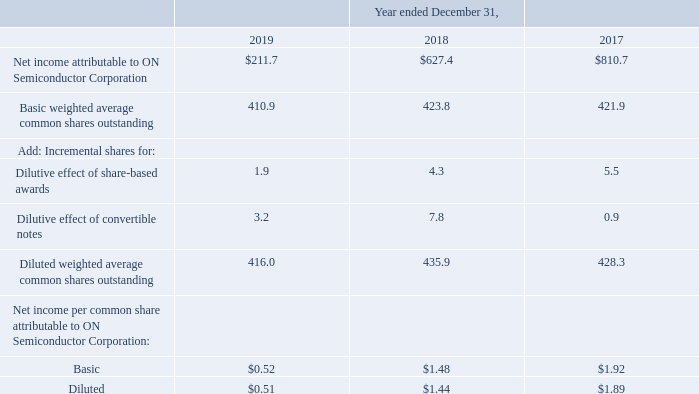Earnings Per Share
Calculations of net income per common share attributable to ON Semiconductor Corporation are as follows (in millions, except per share data):
Basic income per common share is computed by dividing net income attributable to ON Semiconductor Corporation by the weighted average number of common shares outstanding during the period.
To calculate the diluted weighted-average common shares outstanding, the number of incremental shares from the assumed exercise of stock options and assumed issuance of shares relating to RSUs is calculated by applying the treasury stock method. Share-based awards whose impact is considered to be anti-dilutive under the treasury stock method were excluded from the diluted net income per share calculation.
The excluded number of anti-dilutive share-based awards was approximately 0.8 million, 0.6 million and 0.2 million for the years ended December 31, 2019, 2018 and 2017, respectively.
The dilutive impact related to the Company’s 1.00% Notes and 1.625% Notes is determined in accordance with the net share settlement requirements, under which the Company’s convertible notes are assumed to be convertible into cash up to the par value, with the excess of par value being convertible into common stock.
Additionally, if the average price of the Company’s common stock exceeds $ 25.96 per share, with respect to the 1.00% Notes, or $30.70 per share, with respect to the 1.625% Notes, during the relevant reporting period, the effect of the additional potential shares that may be issued related to the warrants that were issued concurrently with the issuance of the convertible notes will also be included in the calculation of diluted weighted-average common shares outstanding.
Prior to conversion, the convertible note hedges are not considered for purposes of the earnings per share calculations, as their effect would be anti-dilutive. Upon conversion, the convertible note hedges are expected to offset the dilutive effect of the 1.00% Notes and 1.625% Notes, respectively, when the stock price is above $18.50 per share, with respect to the 1.00% Notes, and $20.72 per share, with respect to the 1.625% Notes.
How is Basic income per common share computed? Dividing net income attributable to on semiconductor corporation by the weighted average number of common shares outstanding during the period. How much is the excluded number of anti-dilutive share-based awards for the year ended December 31, 2019? 0.8 million. How much is the excluded number of anti-dilutive share-based awards for the year ended December 31, 2018? 0.6 million. What is the change in Net income attributable to ON Semiconductor Corporation from December 31, 2018 to 2019?
Answer scale should be: million. 211.7-627.4
Answer: -415.7. What is the change in Basic weighted average common shares outstanding from year ended December 31, 2018 to 2019?
Answer scale should be: million. 410.9-423.8
Answer: -12.9. What is the average Net income attributable to ON Semiconductor Corporation for December 31, 2018 to 2019?
Answer scale should be: million. (211.7+627.4) / 2
Answer: 419.55. 